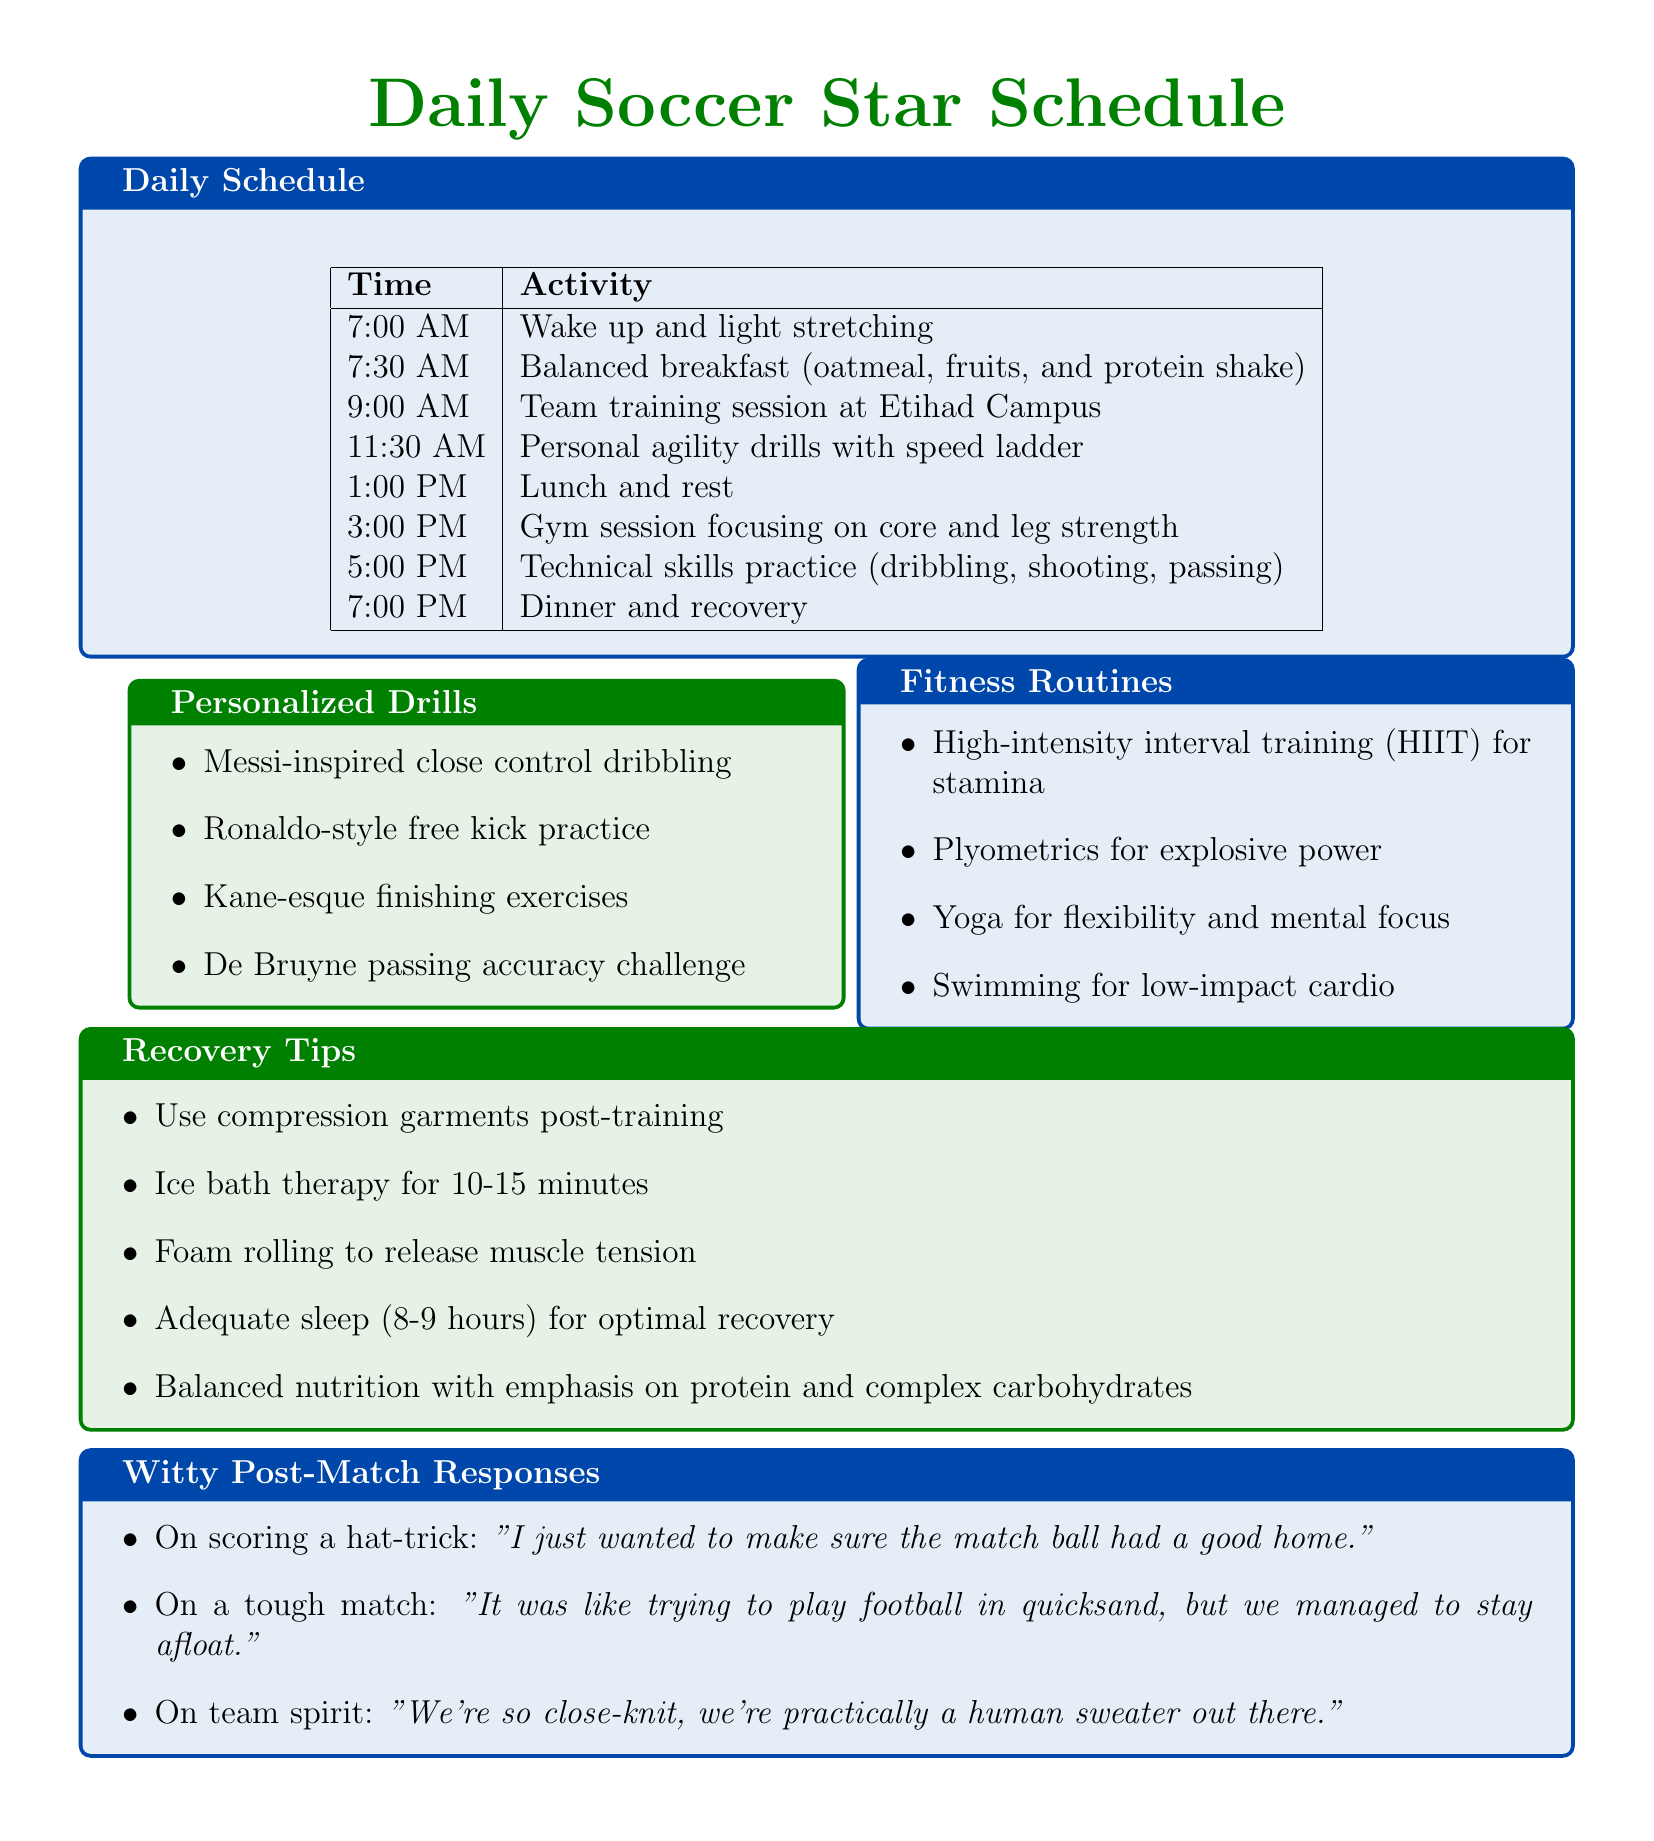What time is the gym session? The gym session is scheduled at 3:00 PM, as indicated in the daily schedule.
Answer: 3:00 PM What is the focus of the team training session? The team training session is held at Etihad Campus, which involves various team tactics and strategies.
Answer: Team training session How long should the ice bath therapy last? The document specifies that ice bath therapy should last for 10-15 minutes as part of the recovery tips.
Answer: 10-15 minutes Which personalized drill is inspired by Messi? The note explicitly mentions "Messi-inspired close control dribbling" as part of the personalized drills section.
Answer: Messi-inspired close control dribbling What fitness routine is suggested for mental focus? The fitness routine that promotes mental focus is yoga, as listed in the fitness routines section.
Answer: Yoga What time is dinner and recovery scheduled? According to the daily schedule, dinner and recovery are scheduled for 7:00 PM.
Answer: 7:00 PM How many types of recovery tips are listed? There are five recovery tips provided in the document for optimal post-training recovery.
Answer: Five Which famous player’s free kick practice is included in personalized drills? The document includes "Ronaldo-style free kick practice" as a personalized drill.
Answer: Ronaldo-style free kick practice 